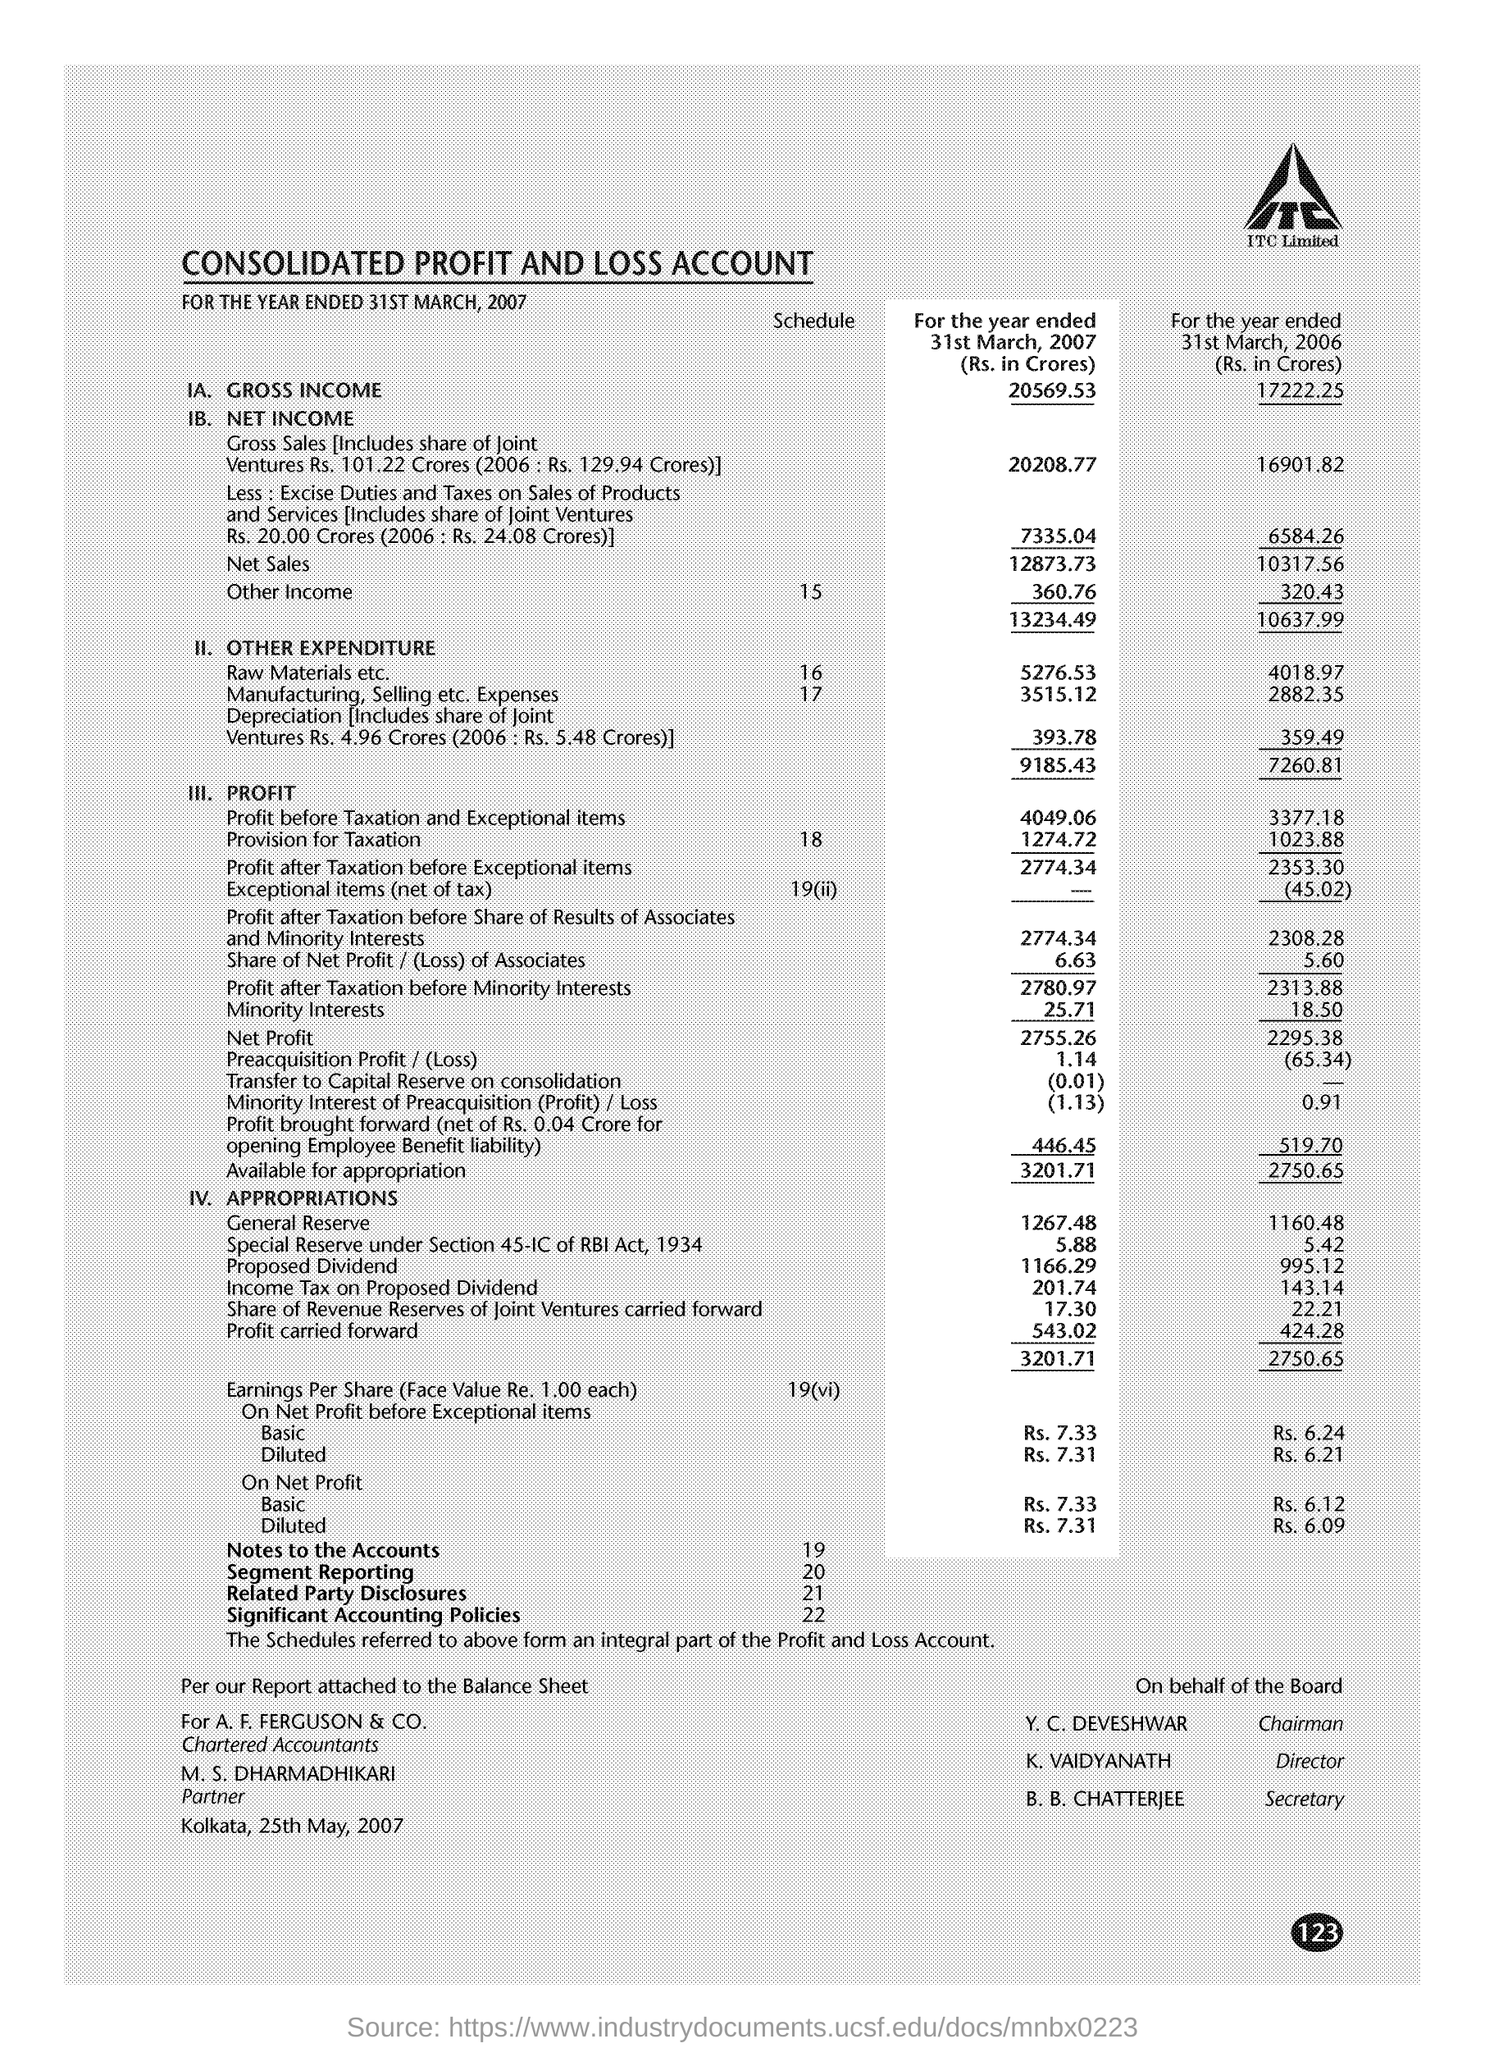List a handful of essential elements in this visual. Y.C. DEVESHWAR is the chairman. Special reserve is created under Section 45-IC of the Reserve Bank of India Act, 1934. 